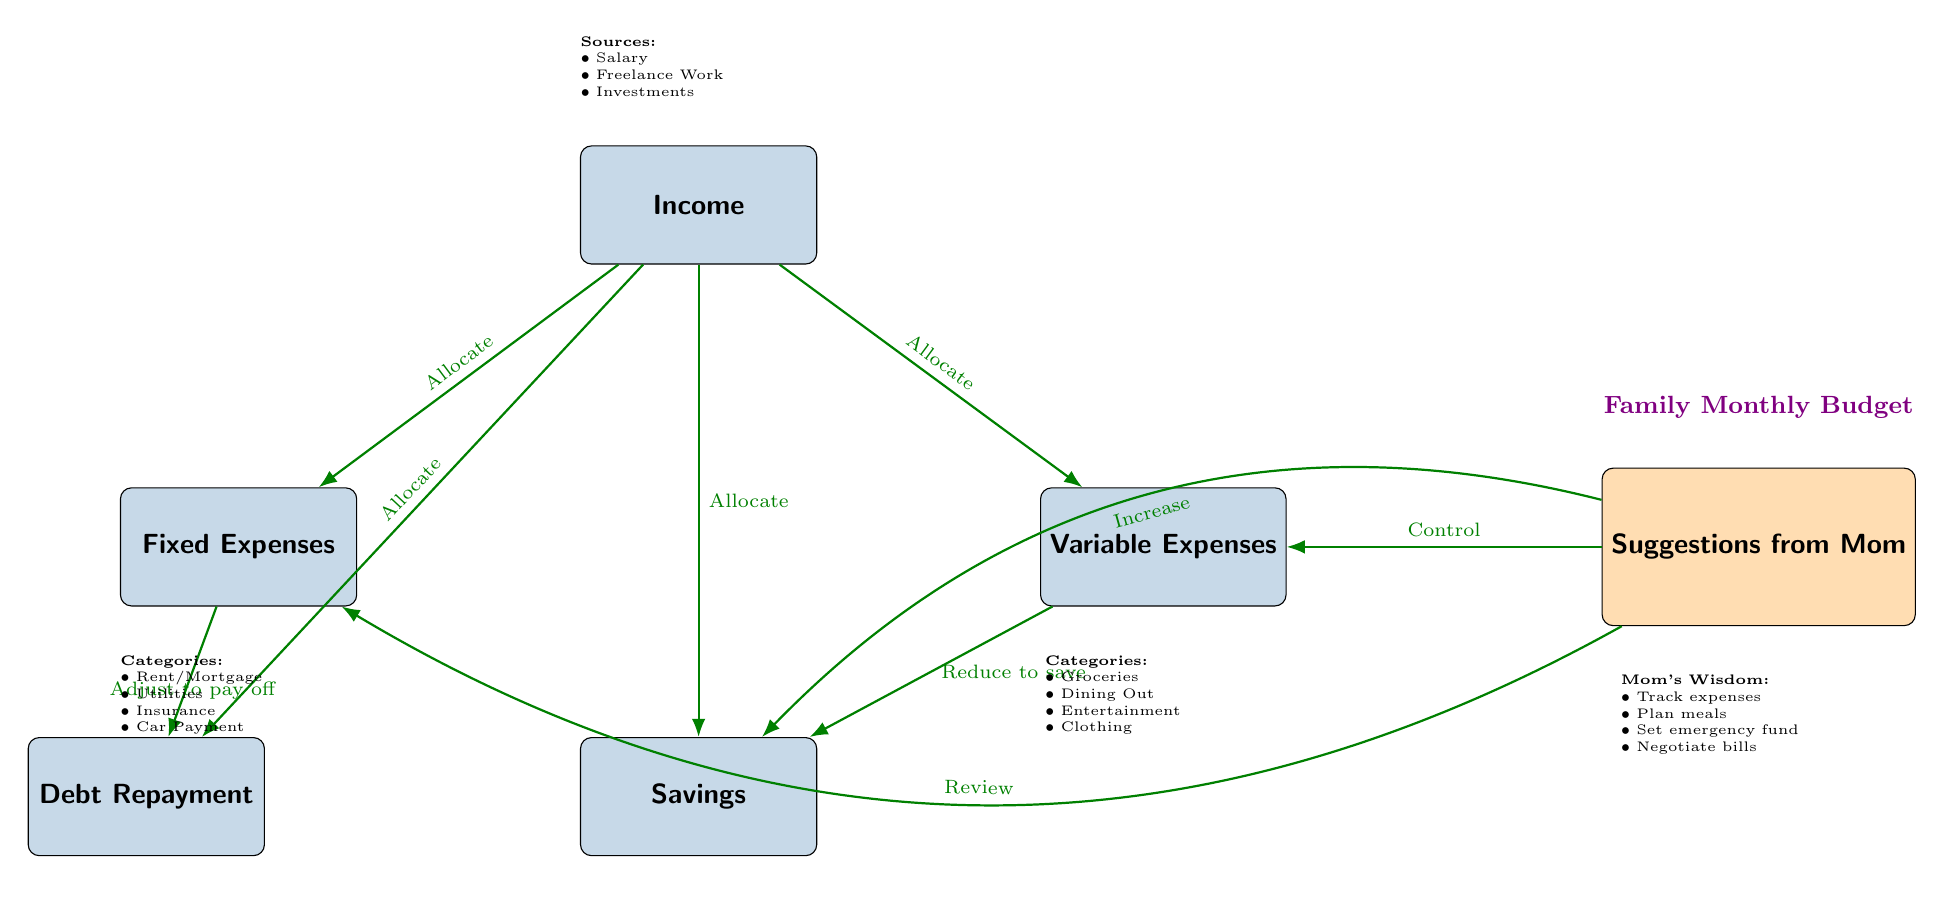What are the types of expenses listed under Fixed Expenses? The diagram specifies categories under Fixed Expenses, which includes Rent/Mortgage, Utilities, Insurance, and Car Payment. This information is directly taken from the node labeled 'Fixed Expenses' where those four items are listed.
Answer: Rent/Mortgage, Utilities, Insurance, Car Payment How many edges are present in the diagram? The diagram consists of various connections between nodes, which can be counted by identifying each directed arrow. There are a total of 8 directed edges shown in the diagram.
Answer: 8 What is one suggestion from Mom regarding the budget? The suggestion node lists several pieces of advice from Mom. One of these suggestions is to "Track expenses," which is specified in the node under the title 'Mom's Wisdom.' It is one of the four suggestions provided.
Answer: Track expenses What should be done to savings according to the suggestions? In the diagram, the suggestion regarding savings indicates that one should "Increase" the savings. This is derived from the connection leading from the suggestions node to the savings node with the label "Increase."
Answer: Increase What is the relationship between Fixed Expenses and Debt Repayment? The diagram presents a directed edge between Fixed Expenses and Debt Repayment. The edge is labeled "Adjust to pay off," which indicates that the amount allocated to Fixed Expenses should be adjusted in order to facilitate paying off debt, demonstrating a directional flow of financial management.
Answer: Adjust to pay off What types of income sources are mentioned in the diagram? The diagram lists various sources of income in the node labeled 'Income.' These include Salary, Freelance Work, and Investments, which are directly indicated in the sources section.
Answer: Salary, Freelance Work, Investments How does the diagram suggest managing Variable Expenses? According to the diagram, there is a directed edge from the suggestions to the Variable Expenses node that is labeled "Control." This implies that the budget suggests controlling the spending in the Variable Expenses category, which helps prioritize expenses.
Answer: Control What is an action to take regarding savings based on the diagram? The suggestion from the diagram that involves savings indicates that "Reduce to save" is an action taken towards Variable Expenses. The connection from Variable Expenses to Savings shows that controlling Variable Expenses helps free up funds to increase Savings.
Answer: Reduce to save 